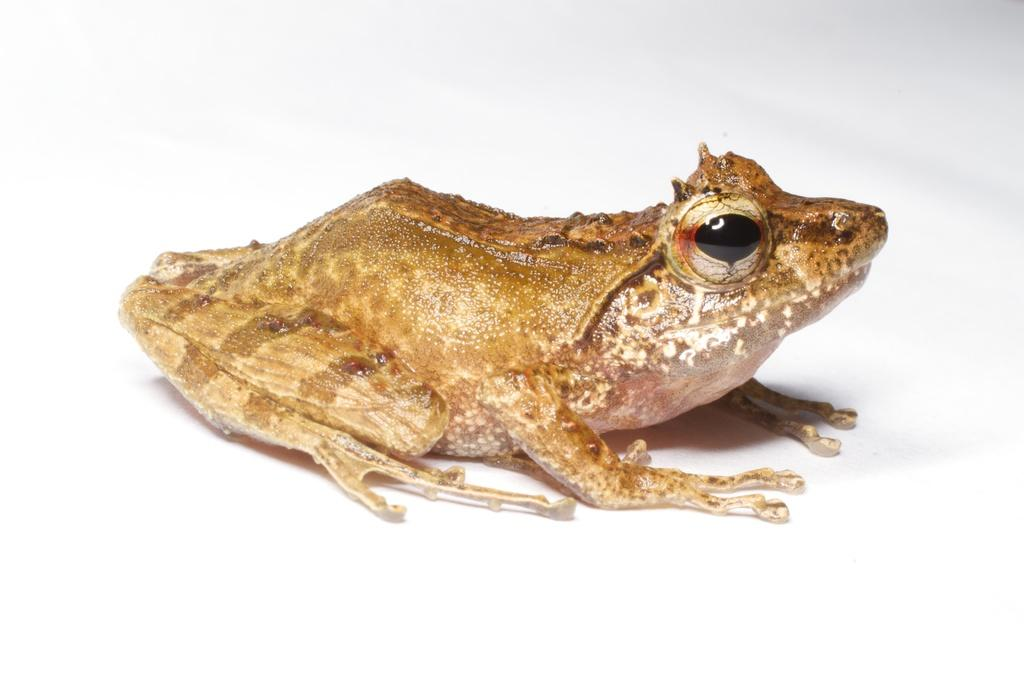What type of animal is in the image? There is a frog in the image. What is the frog sitting on or attached to? The frog is on an object. What type of ball is the frog playing with in the image? There is no ball present in the image; it only features a frog on an object. 